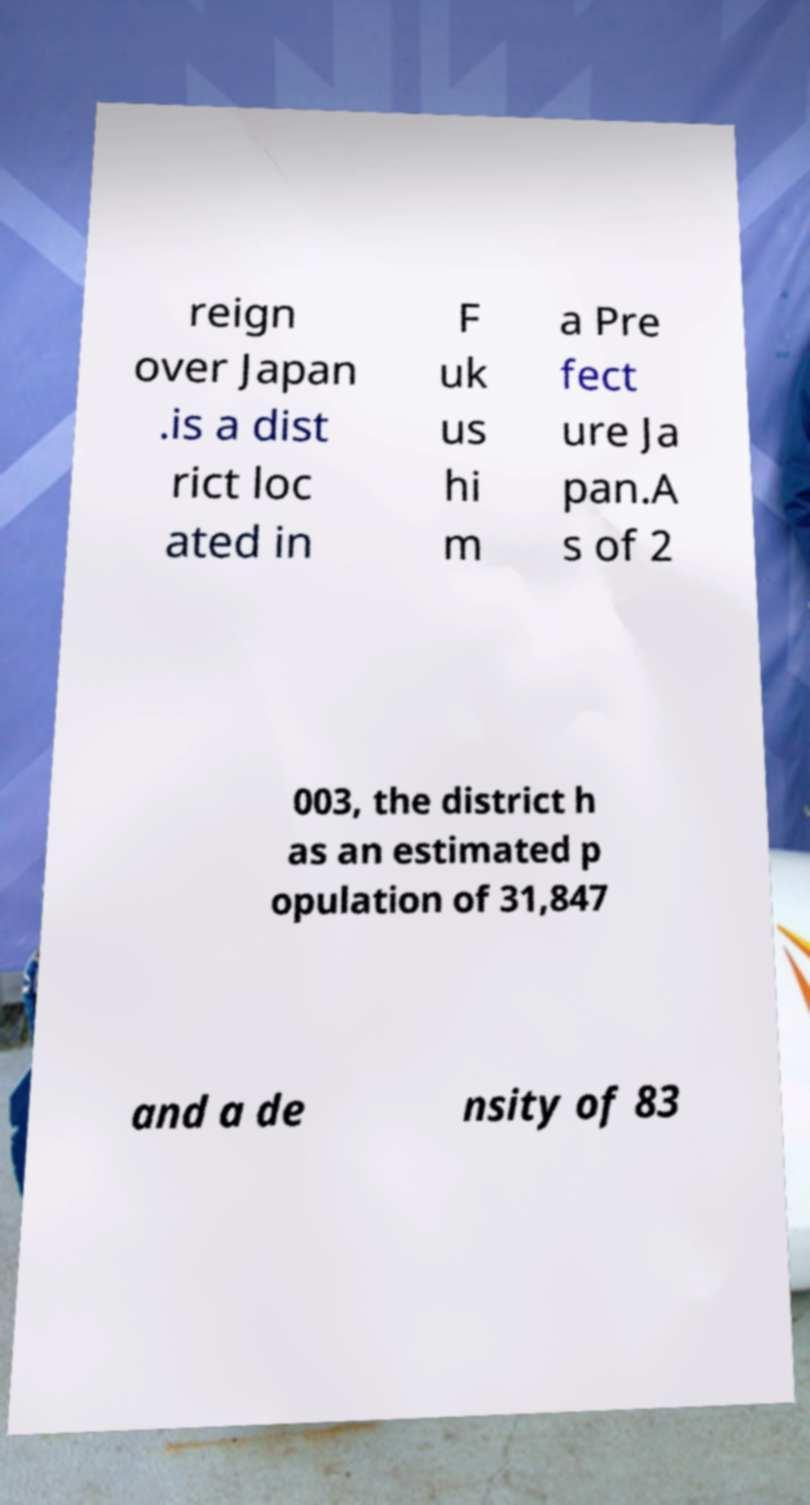Please read and relay the text visible in this image. What does it say? reign over Japan .is a dist rict loc ated in F uk us hi m a Pre fect ure Ja pan.A s of 2 003, the district h as an estimated p opulation of 31,847 and a de nsity of 83 